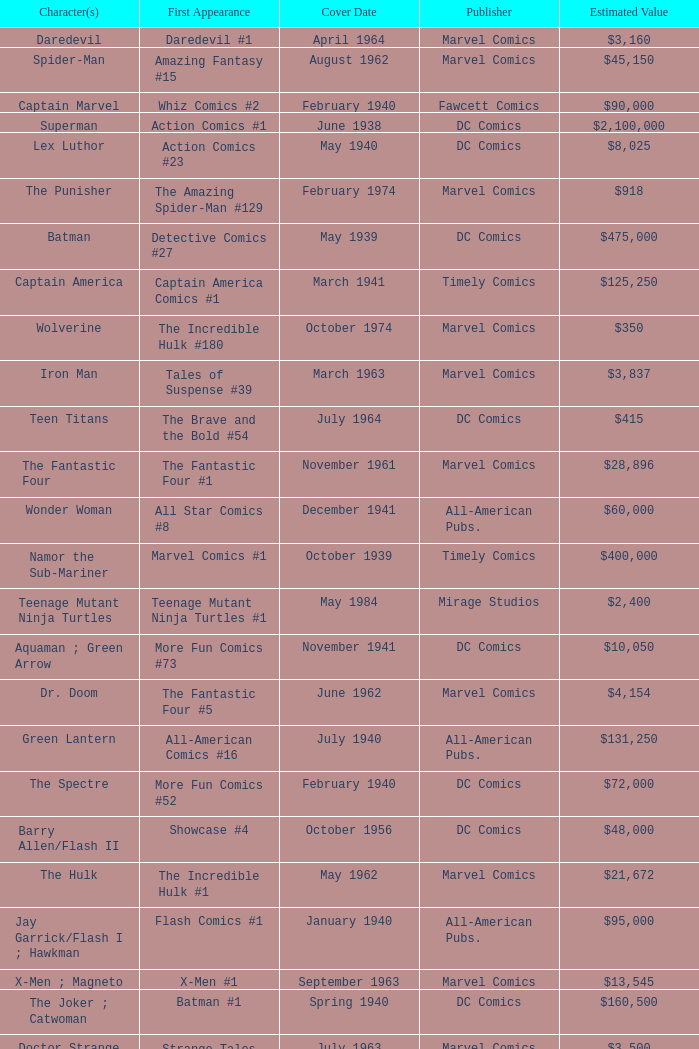Who publishes Wolverine? Marvel Comics. 